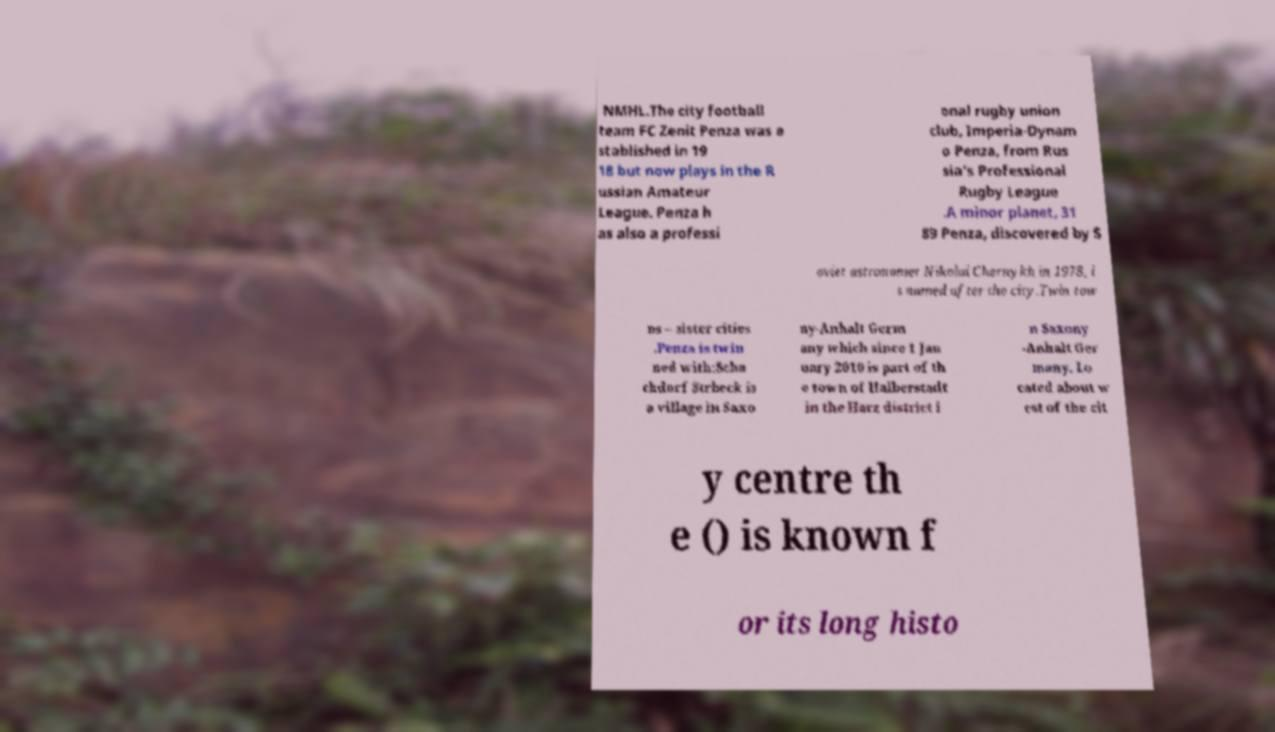I need the written content from this picture converted into text. Can you do that? NMHL.The city football team FC Zenit Penza was e stablished in 19 18 but now plays in the R ussian Amateur League. Penza h as also a professi onal rugby union club, Imperia-Dynam o Penza, from Rus sia's Professional Rugby League .A minor planet, 31 89 Penza, discovered by S oviet astronomer Nikolai Chernykh in 1978, i s named after the city.Twin tow ns – sister cities .Penza is twin ned with:Scha chdorf Strbeck is a village in Saxo ny-Anhalt Germ any which since 1 Jan uary 2010 is part of th e town of Halberstadt in the Harz district i n Saxony -Anhalt Ger many. Lo cated about w est of the cit y centre th e () is known f or its long histo 